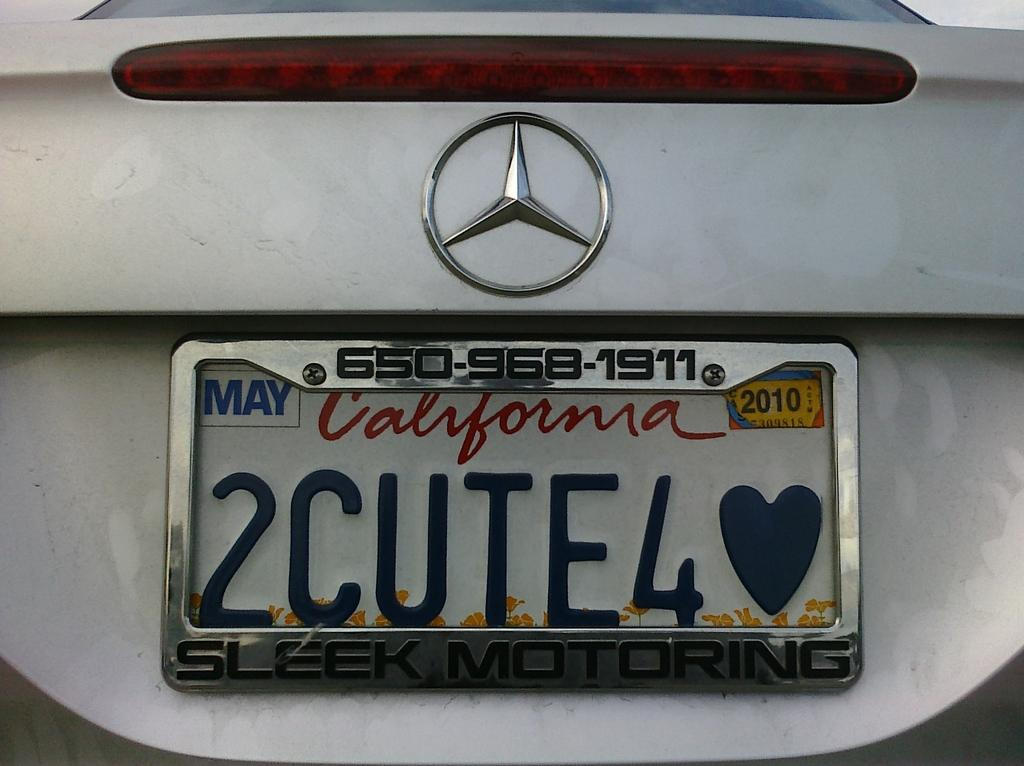Provide a one-sentence caption for the provided image. A Mercedes with a California tag on it that says 2Cute4<3. 